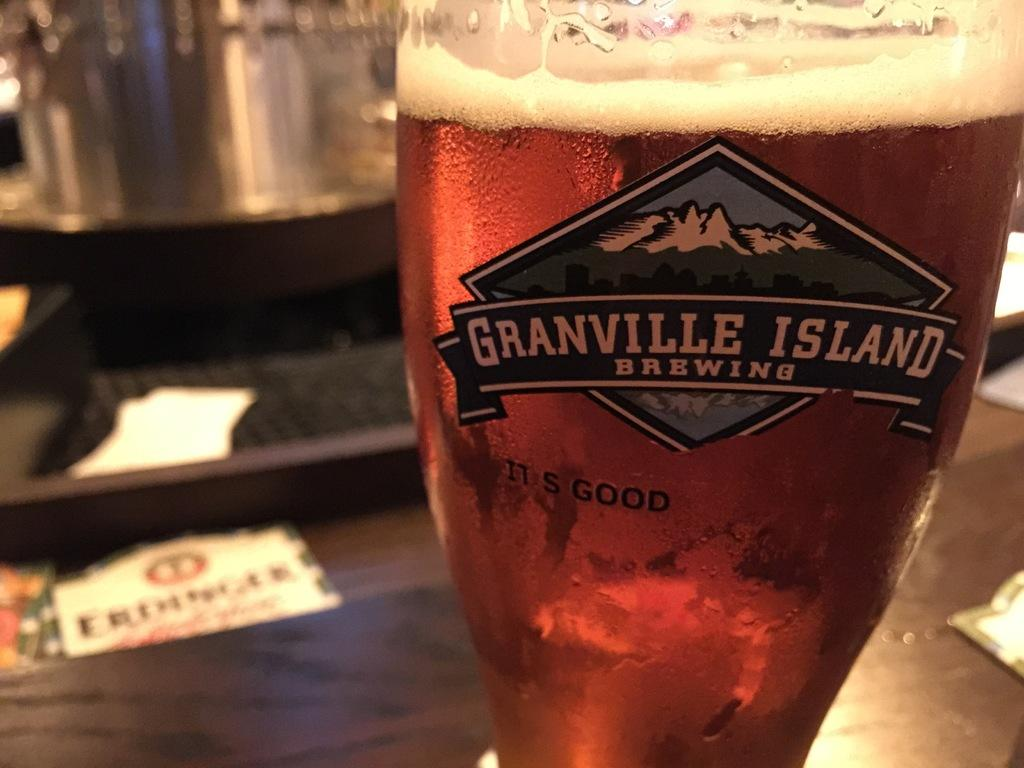<image>
Summarize the visual content of the image. Granville Island brews good beer and has a mountain for their logo. 